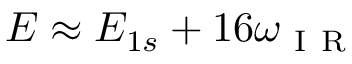Convert formula to latex. <formula><loc_0><loc_0><loc_500><loc_500>E \approx E _ { 1 s } + 1 6 \omega _ { I R }</formula> 